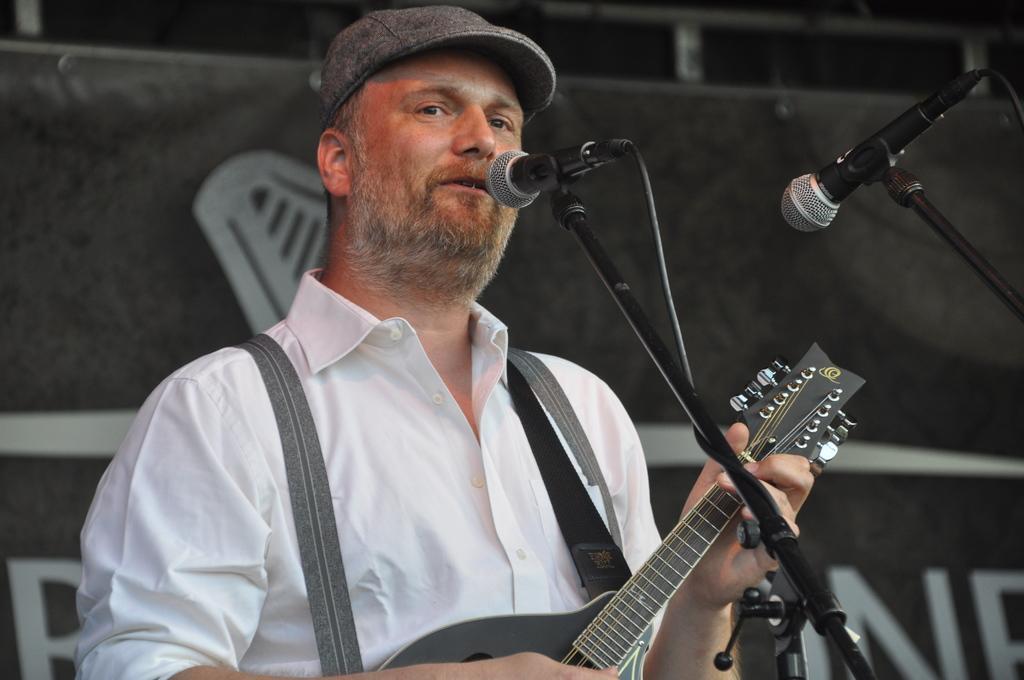Describe this image in one or two sentences. a person is holding a guitar. in front of him there are 2 microphones. 